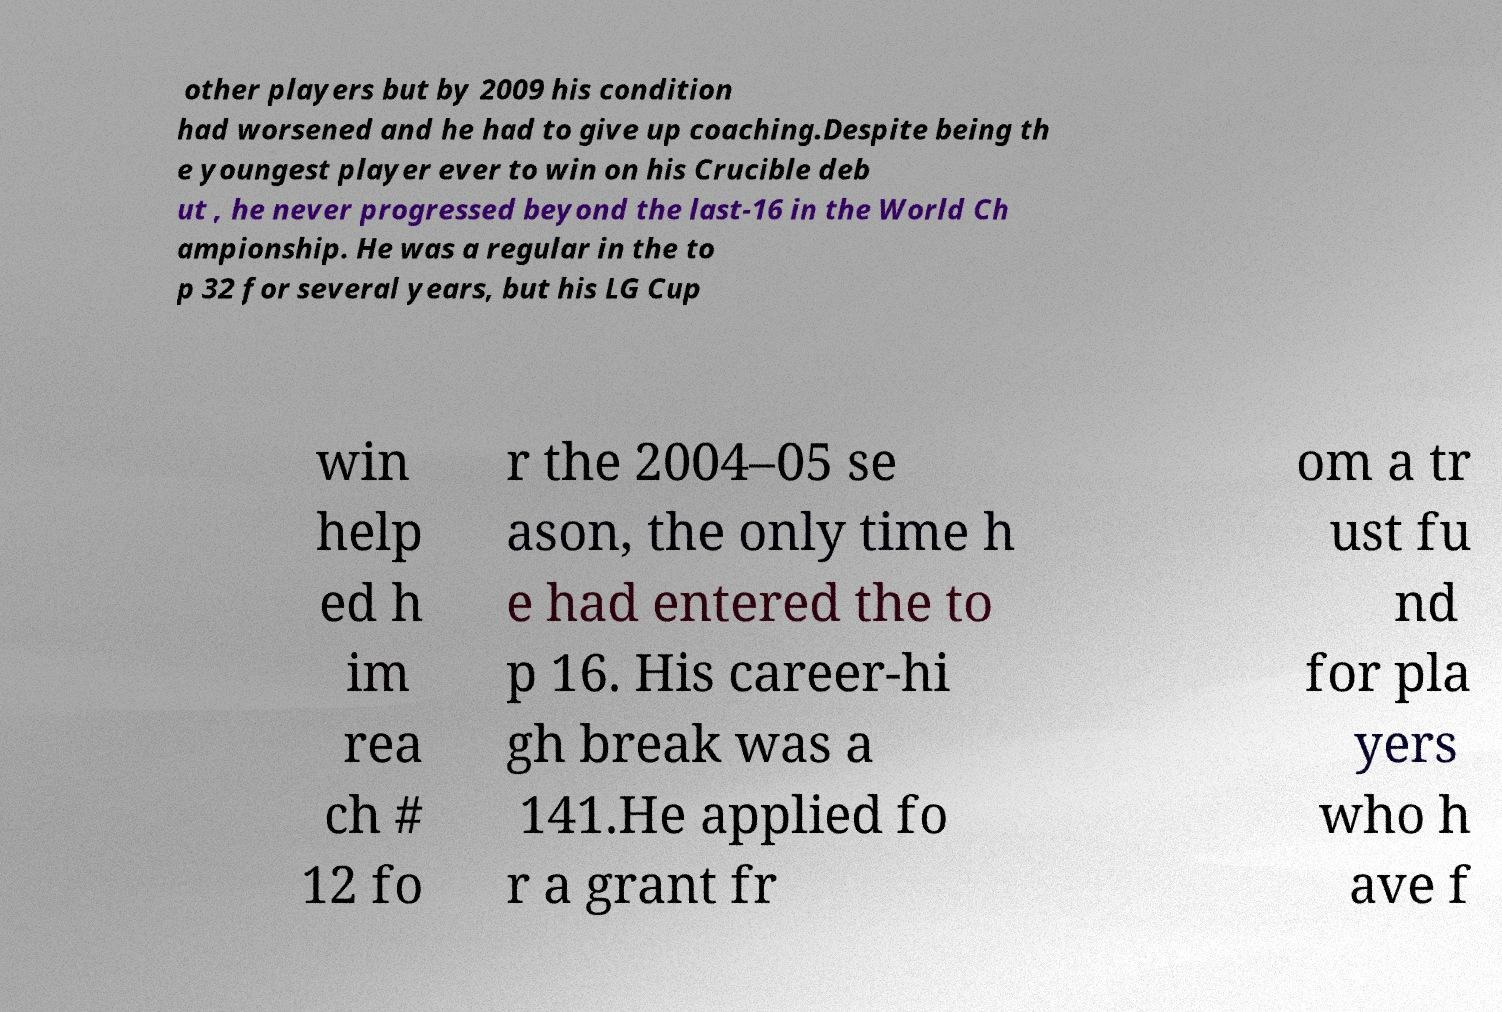Please read and relay the text visible in this image. What does it say? other players but by 2009 his condition had worsened and he had to give up coaching.Despite being th e youngest player ever to win on his Crucible deb ut , he never progressed beyond the last-16 in the World Ch ampionship. He was a regular in the to p 32 for several years, but his LG Cup win help ed h im rea ch # 12 fo r the 2004–05 se ason, the only time h e had entered the to p 16. His career-hi gh break was a 141.He applied fo r a grant fr om a tr ust fu nd for pla yers who h ave f 